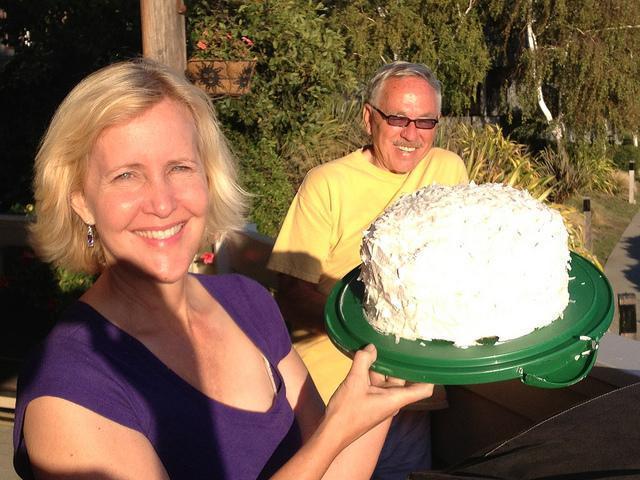The frosting is probably made from what?
Select the accurate answer and provide justification: `Answer: choice
Rationale: srationale.`
Options: Buttercream, honey, chocolate, fondant. Answer: buttercream.
Rationale: Given the white splotchy texture of this cakes frosting buttercream is the only possible main ingredient of those listed here. 